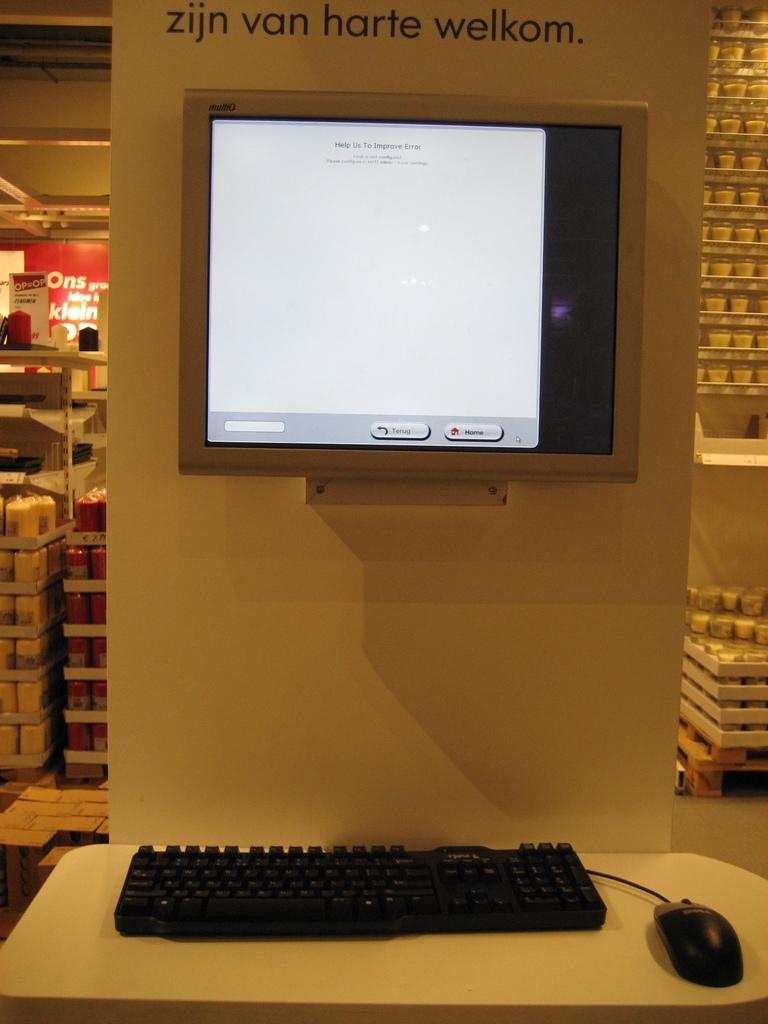What is the last word of the text?
Make the answer very short. Welkom. What is the first lettter of the tect on the top?
Provide a succinct answer. Z. 